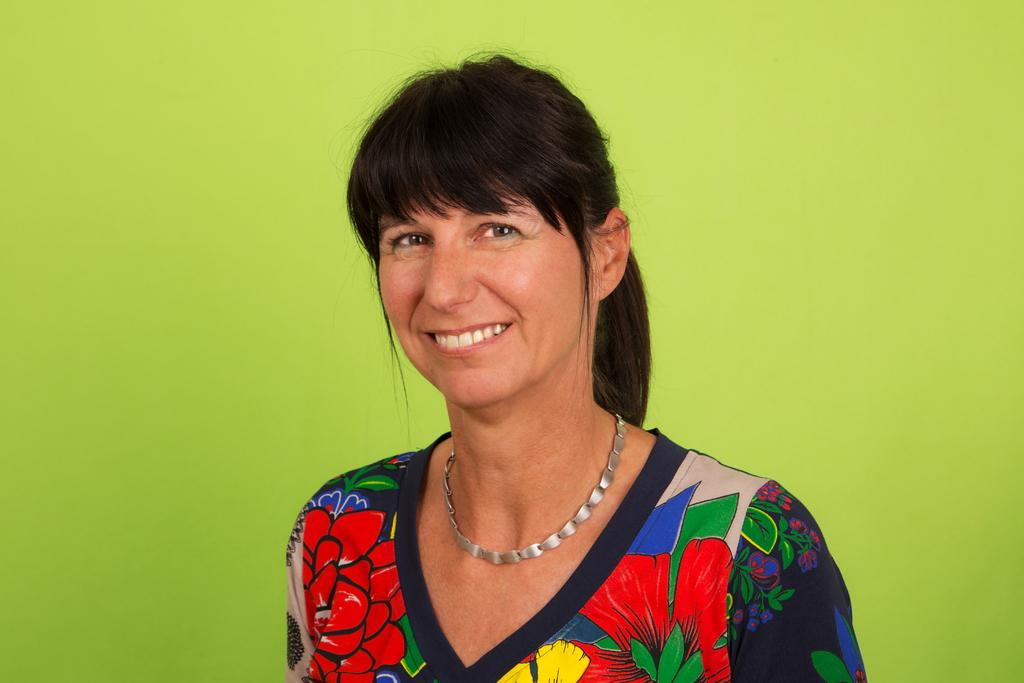Who is present in the image? There is a woman in the image. What is the woman doing in the image? The woman is standing and smiling. What can be seen in the background of the image? The background of the image is green in color. What type of stitch is the woman using to sew a scene in the image? There is no indication in the image that the woman is sewing or that there is a scene present. 